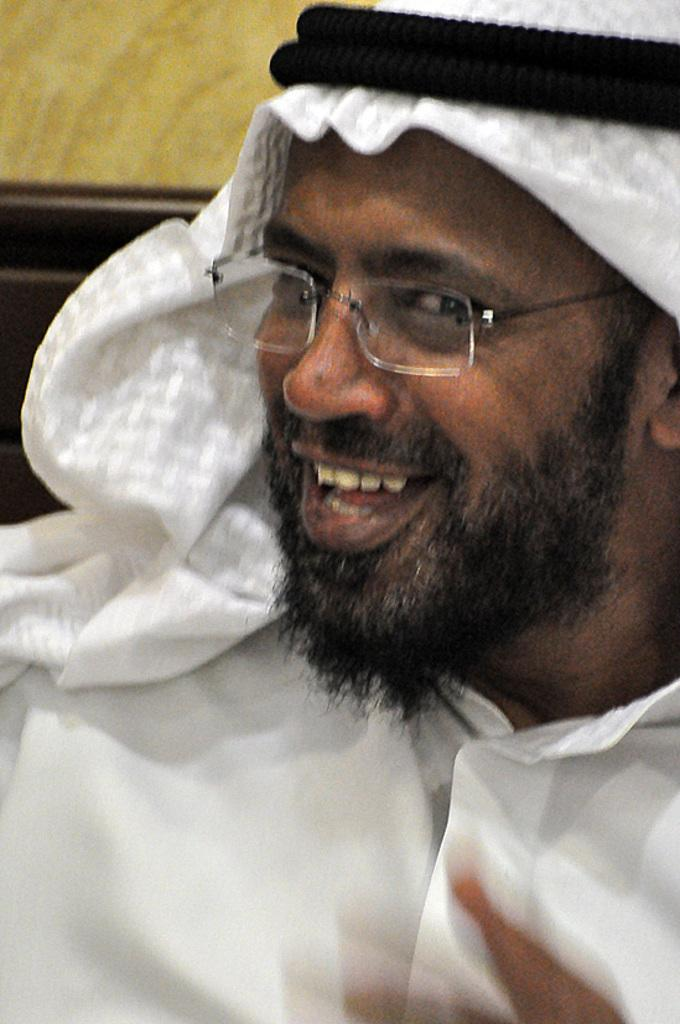Who is the main subject in the image? There is a person in the center of the image. What is the person doing in the image? The person is smiling. What accessory is the person wearing in the image? The person is wearing glasses. What is the person wearing that is not typical clothing? The person is wearing a different costume. How would you describe the background of the image? The background of the image is blurred. What type of leaf is being used as a bit in the image? There is no leaf or bit present in the image. 